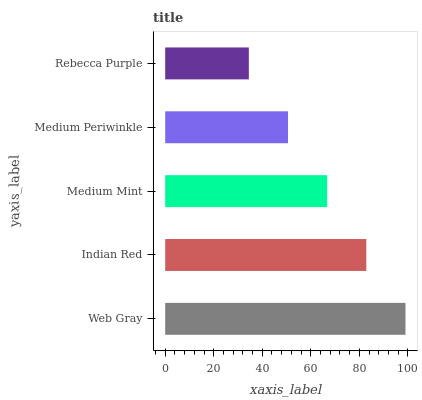Is Rebecca Purple the minimum?
Answer yes or no. Yes. Is Web Gray the maximum?
Answer yes or no. Yes. Is Indian Red the minimum?
Answer yes or no. No. Is Indian Red the maximum?
Answer yes or no. No. Is Web Gray greater than Indian Red?
Answer yes or no. Yes. Is Indian Red less than Web Gray?
Answer yes or no. Yes. Is Indian Red greater than Web Gray?
Answer yes or no. No. Is Web Gray less than Indian Red?
Answer yes or no. No. Is Medium Mint the high median?
Answer yes or no. Yes. Is Medium Mint the low median?
Answer yes or no. Yes. Is Web Gray the high median?
Answer yes or no. No. Is Rebecca Purple the low median?
Answer yes or no. No. 